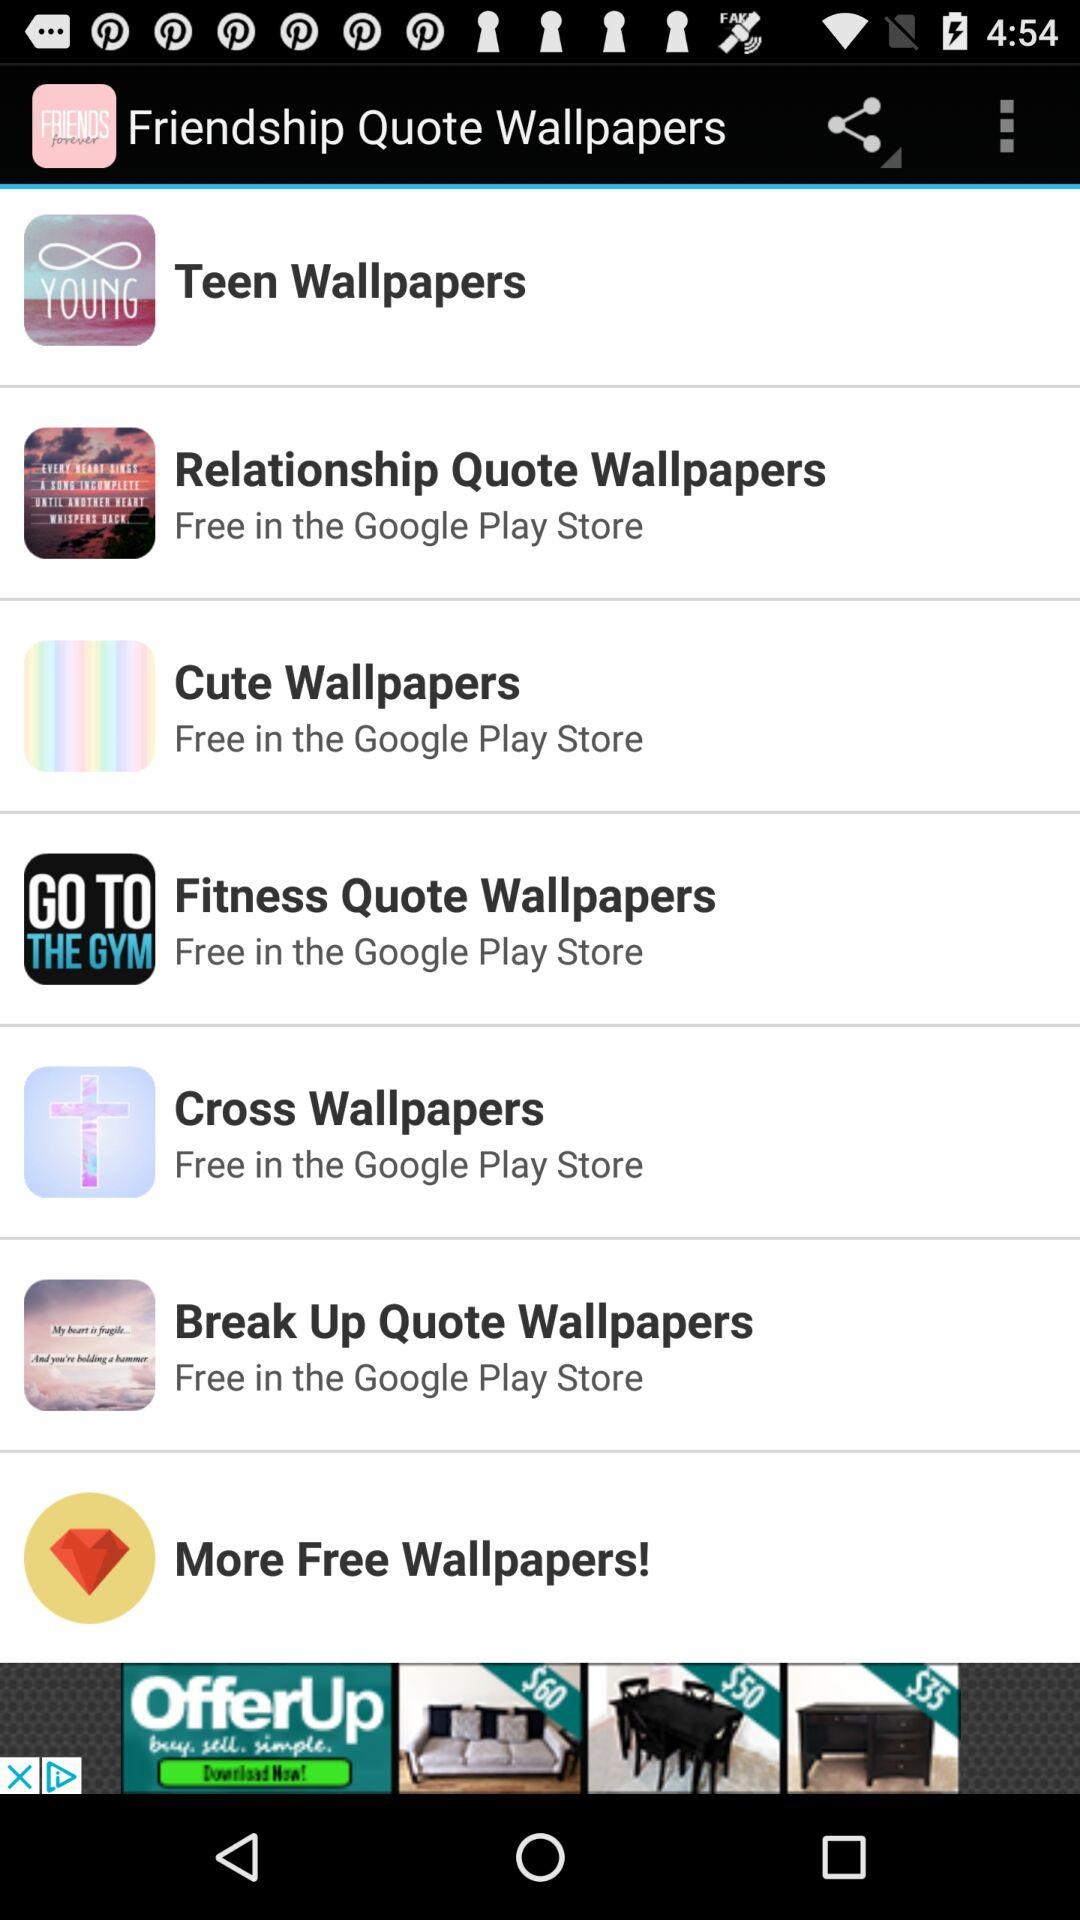What is the application name? The application name is "Friendship Quote Wallpapers". 